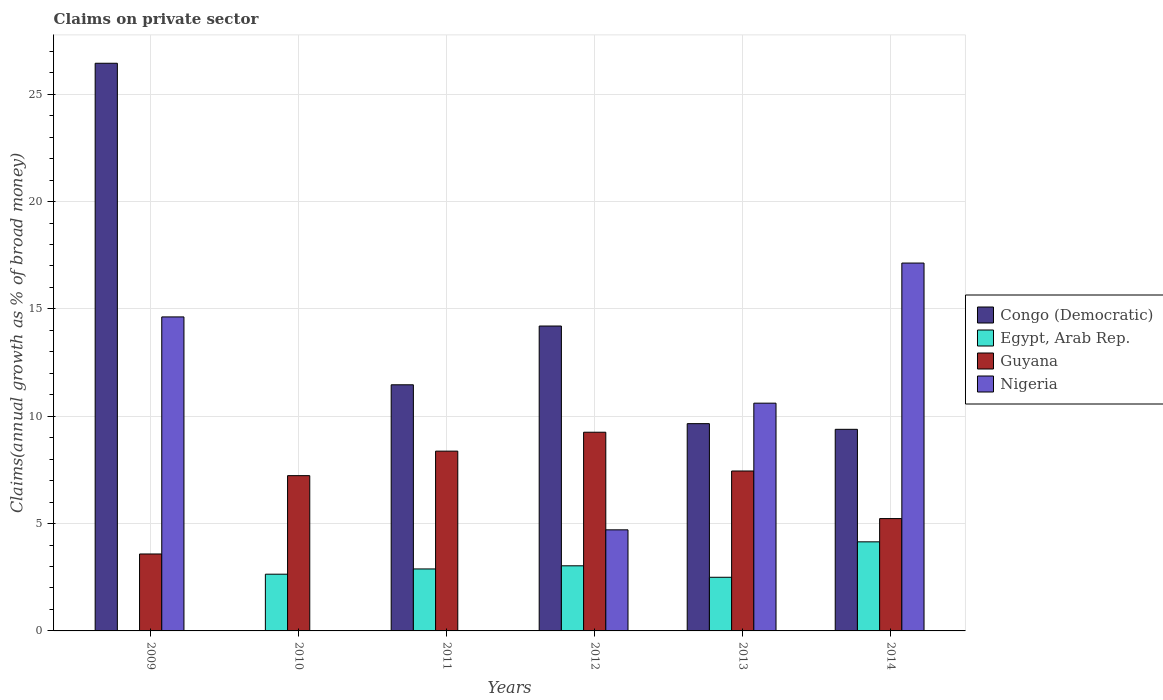How many different coloured bars are there?
Keep it short and to the point. 4. How many groups of bars are there?
Ensure brevity in your answer.  6. How many bars are there on the 2nd tick from the right?
Your answer should be compact. 4. In how many cases, is the number of bars for a given year not equal to the number of legend labels?
Your answer should be very brief. 3. What is the percentage of broad money claimed on private sector in Guyana in 2013?
Give a very brief answer. 7.45. Across all years, what is the maximum percentage of broad money claimed on private sector in Nigeria?
Offer a terse response. 17.13. What is the total percentage of broad money claimed on private sector in Nigeria in the graph?
Give a very brief answer. 47.08. What is the difference between the percentage of broad money claimed on private sector in Guyana in 2009 and that in 2014?
Make the answer very short. -1.65. What is the difference between the percentage of broad money claimed on private sector in Guyana in 2010 and the percentage of broad money claimed on private sector in Egypt, Arab Rep. in 2014?
Provide a short and direct response. 3.08. What is the average percentage of broad money claimed on private sector in Egypt, Arab Rep. per year?
Your response must be concise. 2.54. In the year 2009, what is the difference between the percentage of broad money claimed on private sector in Guyana and percentage of broad money claimed on private sector in Congo (Democratic)?
Give a very brief answer. -22.86. What is the ratio of the percentage of broad money claimed on private sector in Guyana in 2011 to that in 2012?
Your answer should be very brief. 0.9. Is the percentage of broad money claimed on private sector in Guyana in 2011 less than that in 2012?
Your response must be concise. Yes. Is the difference between the percentage of broad money claimed on private sector in Guyana in 2011 and 2014 greater than the difference between the percentage of broad money claimed on private sector in Congo (Democratic) in 2011 and 2014?
Your answer should be compact. Yes. What is the difference between the highest and the second highest percentage of broad money claimed on private sector in Guyana?
Your response must be concise. 0.88. What is the difference between the highest and the lowest percentage of broad money claimed on private sector in Congo (Democratic)?
Make the answer very short. 26.44. Is the sum of the percentage of broad money claimed on private sector in Congo (Democratic) in 2012 and 2013 greater than the maximum percentage of broad money claimed on private sector in Egypt, Arab Rep. across all years?
Your answer should be compact. Yes. Is it the case that in every year, the sum of the percentage of broad money claimed on private sector in Congo (Democratic) and percentage of broad money claimed on private sector in Guyana is greater than the sum of percentage of broad money claimed on private sector in Nigeria and percentage of broad money claimed on private sector in Egypt, Arab Rep.?
Offer a very short reply. No. Is it the case that in every year, the sum of the percentage of broad money claimed on private sector in Congo (Democratic) and percentage of broad money claimed on private sector in Guyana is greater than the percentage of broad money claimed on private sector in Egypt, Arab Rep.?
Provide a short and direct response. Yes. How many bars are there?
Give a very brief answer. 20. Are all the bars in the graph horizontal?
Offer a terse response. No. How many years are there in the graph?
Give a very brief answer. 6. Does the graph contain any zero values?
Your answer should be very brief. Yes. Does the graph contain grids?
Make the answer very short. Yes. Where does the legend appear in the graph?
Your response must be concise. Center right. What is the title of the graph?
Give a very brief answer. Claims on private sector. Does "Switzerland" appear as one of the legend labels in the graph?
Provide a short and direct response. No. What is the label or title of the X-axis?
Your answer should be compact. Years. What is the label or title of the Y-axis?
Your answer should be very brief. Claims(annual growth as % of broad money). What is the Claims(annual growth as % of broad money) of Congo (Democratic) in 2009?
Provide a short and direct response. 26.44. What is the Claims(annual growth as % of broad money) of Egypt, Arab Rep. in 2009?
Provide a short and direct response. 0. What is the Claims(annual growth as % of broad money) of Guyana in 2009?
Offer a very short reply. 3.58. What is the Claims(annual growth as % of broad money) in Nigeria in 2009?
Your answer should be very brief. 14.63. What is the Claims(annual growth as % of broad money) of Congo (Democratic) in 2010?
Your answer should be very brief. 0. What is the Claims(annual growth as % of broad money) of Egypt, Arab Rep. in 2010?
Provide a short and direct response. 2.64. What is the Claims(annual growth as % of broad money) of Guyana in 2010?
Give a very brief answer. 7.23. What is the Claims(annual growth as % of broad money) of Nigeria in 2010?
Offer a terse response. 0. What is the Claims(annual growth as % of broad money) of Congo (Democratic) in 2011?
Your answer should be compact. 11.46. What is the Claims(annual growth as % of broad money) of Egypt, Arab Rep. in 2011?
Your response must be concise. 2.89. What is the Claims(annual growth as % of broad money) of Guyana in 2011?
Make the answer very short. 8.37. What is the Claims(annual growth as % of broad money) of Nigeria in 2011?
Offer a very short reply. 0. What is the Claims(annual growth as % of broad money) in Congo (Democratic) in 2012?
Your response must be concise. 14.2. What is the Claims(annual growth as % of broad money) of Egypt, Arab Rep. in 2012?
Provide a succinct answer. 3.03. What is the Claims(annual growth as % of broad money) in Guyana in 2012?
Provide a succinct answer. 9.25. What is the Claims(annual growth as % of broad money) in Nigeria in 2012?
Ensure brevity in your answer.  4.71. What is the Claims(annual growth as % of broad money) of Congo (Democratic) in 2013?
Ensure brevity in your answer.  9.65. What is the Claims(annual growth as % of broad money) of Egypt, Arab Rep. in 2013?
Your answer should be compact. 2.5. What is the Claims(annual growth as % of broad money) in Guyana in 2013?
Your response must be concise. 7.45. What is the Claims(annual growth as % of broad money) in Nigeria in 2013?
Your response must be concise. 10.61. What is the Claims(annual growth as % of broad money) in Congo (Democratic) in 2014?
Provide a succinct answer. 9.39. What is the Claims(annual growth as % of broad money) in Egypt, Arab Rep. in 2014?
Your answer should be compact. 4.15. What is the Claims(annual growth as % of broad money) in Guyana in 2014?
Make the answer very short. 5.23. What is the Claims(annual growth as % of broad money) in Nigeria in 2014?
Your answer should be compact. 17.13. Across all years, what is the maximum Claims(annual growth as % of broad money) in Congo (Democratic)?
Ensure brevity in your answer.  26.44. Across all years, what is the maximum Claims(annual growth as % of broad money) in Egypt, Arab Rep.?
Offer a terse response. 4.15. Across all years, what is the maximum Claims(annual growth as % of broad money) of Guyana?
Offer a very short reply. 9.25. Across all years, what is the maximum Claims(annual growth as % of broad money) of Nigeria?
Provide a short and direct response. 17.13. Across all years, what is the minimum Claims(annual growth as % of broad money) in Congo (Democratic)?
Your answer should be compact. 0. Across all years, what is the minimum Claims(annual growth as % of broad money) in Guyana?
Offer a terse response. 3.58. What is the total Claims(annual growth as % of broad money) of Congo (Democratic) in the graph?
Your response must be concise. 71.15. What is the total Claims(annual growth as % of broad money) in Egypt, Arab Rep. in the graph?
Your response must be concise. 15.21. What is the total Claims(annual growth as % of broad money) of Guyana in the graph?
Your response must be concise. 41.13. What is the total Claims(annual growth as % of broad money) in Nigeria in the graph?
Provide a short and direct response. 47.08. What is the difference between the Claims(annual growth as % of broad money) in Guyana in 2009 and that in 2010?
Give a very brief answer. -3.65. What is the difference between the Claims(annual growth as % of broad money) of Congo (Democratic) in 2009 and that in 2011?
Your answer should be very brief. 14.98. What is the difference between the Claims(annual growth as % of broad money) in Guyana in 2009 and that in 2011?
Your answer should be very brief. -4.79. What is the difference between the Claims(annual growth as % of broad money) of Congo (Democratic) in 2009 and that in 2012?
Your response must be concise. 12.24. What is the difference between the Claims(annual growth as % of broad money) of Guyana in 2009 and that in 2012?
Keep it short and to the point. -5.67. What is the difference between the Claims(annual growth as % of broad money) in Nigeria in 2009 and that in 2012?
Give a very brief answer. 9.92. What is the difference between the Claims(annual growth as % of broad money) in Congo (Democratic) in 2009 and that in 2013?
Your answer should be compact. 16.79. What is the difference between the Claims(annual growth as % of broad money) of Guyana in 2009 and that in 2013?
Make the answer very short. -3.87. What is the difference between the Claims(annual growth as % of broad money) in Nigeria in 2009 and that in 2013?
Provide a short and direct response. 4.02. What is the difference between the Claims(annual growth as % of broad money) of Congo (Democratic) in 2009 and that in 2014?
Ensure brevity in your answer.  17.05. What is the difference between the Claims(annual growth as % of broad money) of Guyana in 2009 and that in 2014?
Your answer should be compact. -1.65. What is the difference between the Claims(annual growth as % of broad money) of Nigeria in 2009 and that in 2014?
Give a very brief answer. -2.51. What is the difference between the Claims(annual growth as % of broad money) of Egypt, Arab Rep. in 2010 and that in 2011?
Your answer should be very brief. -0.24. What is the difference between the Claims(annual growth as % of broad money) of Guyana in 2010 and that in 2011?
Give a very brief answer. -1.14. What is the difference between the Claims(annual growth as % of broad money) in Egypt, Arab Rep. in 2010 and that in 2012?
Your response must be concise. -0.39. What is the difference between the Claims(annual growth as % of broad money) of Guyana in 2010 and that in 2012?
Your response must be concise. -2.02. What is the difference between the Claims(annual growth as % of broad money) in Egypt, Arab Rep. in 2010 and that in 2013?
Offer a very short reply. 0.14. What is the difference between the Claims(annual growth as % of broad money) in Guyana in 2010 and that in 2013?
Offer a terse response. -0.22. What is the difference between the Claims(annual growth as % of broad money) of Egypt, Arab Rep. in 2010 and that in 2014?
Give a very brief answer. -1.51. What is the difference between the Claims(annual growth as % of broad money) of Guyana in 2010 and that in 2014?
Your answer should be compact. 2. What is the difference between the Claims(annual growth as % of broad money) in Congo (Democratic) in 2011 and that in 2012?
Offer a very short reply. -2.74. What is the difference between the Claims(annual growth as % of broad money) in Egypt, Arab Rep. in 2011 and that in 2012?
Provide a succinct answer. -0.15. What is the difference between the Claims(annual growth as % of broad money) of Guyana in 2011 and that in 2012?
Provide a succinct answer. -0.88. What is the difference between the Claims(annual growth as % of broad money) in Congo (Democratic) in 2011 and that in 2013?
Keep it short and to the point. 1.81. What is the difference between the Claims(annual growth as % of broad money) of Egypt, Arab Rep. in 2011 and that in 2013?
Your answer should be very brief. 0.39. What is the difference between the Claims(annual growth as % of broad money) in Guyana in 2011 and that in 2013?
Provide a short and direct response. 0.93. What is the difference between the Claims(annual growth as % of broad money) in Congo (Democratic) in 2011 and that in 2014?
Make the answer very short. 2.07. What is the difference between the Claims(annual growth as % of broad money) in Egypt, Arab Rep. in 2011 and that in 2014?
Offer a terse response. -1.26. What is the difference between the Claims(annual growth as % of broad money) of Guyana in 2011 and that in 2014?
Your response must be concise. 3.14. What is the difference between the Claims(annual growth as % of broad money) in Congo (Democratic) in 2012 and that in 2013?
Offer a terse response. 4.55. What is the difference between the Claims(annual growth as % of broad money) in Egypt, Arab Rep. in 2012 and that in 2013?
Your answer should be compact. 0.53. What is the difference between the Claims(annual growth as % of broad money) in Guyana in 2012 and that in 2013?
Keep it short and to the point. 1.81. What is the difference between the Claims(annual growth as % of broad money) in Nigeria in 2012 and that in 2013?
Give a very brief answer. -5.9. What is the difference between the Claims(annual growth as % of broad money) of Congo (Democratic) in 2012 and that in 2014?
Offer a very short reply. 4.81. What is the difference between the Claims(annual growth as % of broad money) of Egypt, Arab Rep. in 2012 and that in 2014?
Give a very brief answer. -1.12. What is the difference between the Claims(annual growth as % of broad money) in Guyana in 2012 and that in 2014?
Offer a very short reply. 4.02. What is the difference between the Claims(annual growth as % of broad money) in Nigeria in 2012 and that in 2014?
Provide a succinct answer. -12.43. What is the difference between the Claims(annual growth as % of broad money) of Congo (Democratic) in 2013 and that in 2014?
Offer a very short reply. 0.26. What is the difference between the Claims(annual growth as % of broad money) in Egypt, Arab Rep. in 2013 and that in 2014?
Ensure brevity in your answer.  -1.65. What is the difference between the Claims(annual growth as % of broad money) in Guyana in 2013 and that in 2014?
Make the answer very short. 2.22. What is the difference between the Claims(annual growth as % of broad money) in Nigeria in 2013 and that in 2014?
Give a very brief answer. -6.53. What is the difference between the Claims(annual growth as % of broad money) of Congo (Democratic) in 2009 and the Claims(annual growth as % of broad money) of Egypt, Arab Rep. in 2010?
Give a very brief answer. 23.8. What is the difference between the Claims(annual growth as % of broad money) in Congo (Democratic) in 2009 and the Claims(annual growth as % of broad money) in Guyana in 2010?
Your response must be concise. 19.21. What is the difference between the Claims(annual growth as % of broad money) of Congo (Democratic) in 2009 and the Claims(annual growth as % of broad money) of Egypt, Arab Rep. in 2011?
Your answer should be very brief. 23.56. What is the difference between the Claims(annual growth as % of broad money) of Congo (Democratic) in 2009 and the Claims(annual growth as % of broad money) of Guyana in 2011?
Provide a short and direct response. 18.07. What is the difference between the Claims(annual growth as % of broad money) in Congo (Democratic) in 2009 and the Claims(annual growth as % of broad money) in Egypt, Arab Rep. in 2012?
Your answer should be very brief. 23.41. What is the difference between the Claims(annual growth as % of broad money) of Congo (Democratic) in 2009 and the Claims(annual growth as % of broad money) of Guyana in 2012?
Offer a very short reply. 17.19. What is the difference between the Claims(annual growth as % of broad money) in Congo (Democratic) in 2009 and the Claims(annual growth as % of broad money) in Nigeria in 2012?
Offer a terse response. 21.73. What is the difference between the Claims(annual growth as % of broad money) in Guyana in 2009 and the Claims(annual growth as % of broad money) in Nigeria in 2012?
Ensure brevity in your answer.  -1.12. What is the difference between the Claims(annual growth as % of broad money) in Congo (Democratic) in 2009 and the Claims(annual growth as % of broad money) in Egypt, Arab Rep. in 2013?
Your answer should be compact. 23.94. What is the difference between the Claims(annual growth as % of broad money) of Congo (Democratic) in 2009 and the Claims(annual growth as % of broad money) of Guyana in 2013?
Give a very brief answer. 18.99. What is the difference between the Claims(annual growth as % of broad money) in Congo (Democratic) in 2009 and the Claims(annual growth as % of broad money) in Nigeria in 2013?
Provide a succinct answer. 15.83. What is the difference between the Claims(annual growth as % of broad money) of Guyana in 2009 and the Claims(annual growth as % of broad money) of Nigeria in 2013?
Ensure brevity in your answer.  -7.03. What is the difference between the Claims(annual growth as % of broad money) of Congo (Democratic) in 2009 and the Claims(annual growth as % of broad money) of Egypt, Arab Rep. in 2014?
Offer a very short reply. 22.29. What is the difference between the Claims(annual growth as % of broad money) of Congo (Democratic) in 2009 and the Claims(annual growth as % of broad money) of Guyana in 2014?
Your response must be concise. 21.21. What is the difference between the Claims(annual growth as % of broad money) of Congo (Democratic) in 2009 and the Claims(annual growth as % of broad money) of Nigeria in 2014?
Offer a very short reply. 9.31. What is the difference between the Claims(annual growth as % of broad money) in Guyana in 2009 and the Claims(annual growth as % of broad money) in Nigeria in 2014?
Provide a short and direct response. -13.55. What is the difference between the Claims(annual growth as % of broad money) of Egypt, Arab Rep. in 2010 and the Claims(annual growth as % of broad money) of Guyana in 2011?
Provide a short and direct response. -5.73. What is the difference between the Claims(annual growth as % of broad money) in Egypt, Arab Rep. in 2010 and the Claims(annual growth as % of broad money) in Guyana in 2012?
Provide a short and direct response. -6.61. What is the difference between the Claims(annual growth as % of broad money) of Egypt, Arab Rep. in 2010 and the Claims(annual growth as % of broad money) of Nigeria in 2012?
Provide a short and direct response. -2.07. What is the difference between the Claims(annual growth as % of broad money) in Guyana in 2010 and the Claims(annual growth as % of broad money) in Nigeria in 2012?
Your answer should be very brief. 2.52. What is the difference between the Claims(annual growth as % of broad money) in Egypt, Arab Rep. in 2010 and the Claims(annual growth as % of broad money) in Guyana in 2013?
Provide a short and direct response. -4.81. What is the difference between the Claims(annual growth as % of broad money) in Egypt, Arab Rep. in 2010 and the Claims(annual growth as % of broad money) in Nigeria in 2013?
Provide a short and direct response. -7.97. What is the difference between the Claims(annual growth as % of broad money) of Guyana in 2010 and the Claims(annual growth as % of broad money) of Nigeria in 2013?
Your answer should be very brief. -3.38. What is the difference between the Claims(annual growth as % of broad money) in Egypt, Arab Rep. in 2010 and the Claims(annual growth as % of broad money) in Guyana in 2014?
Provide a succinct answer. -2.59. What is the difference between the Claims(annual growth as % of broad money) of Egypt, Arab Rep. in 2010 and the Claims(annual growth as % of broad money) of Nigeria in 2014?
Keep it short and to the point. -14.49. What is the difference between the Claims(annual growth as % of broad money) of Guyana in 2010 and the Claims(annual growth as % of broad money) of Nigeria in 2014?
Your response must be concise. -9.9. What is the difference between the Claims(annual growth as % of broad money) of Congo (Democratic) in 2011 and the Claims(annual growth as % of broad money) of Egypt, Arab Rep. in 2012?
Offer a very short reply. 8.43. What is the difference between the Claims(annual growth as % of broad money) in Congo (Democratic) in 2011 and the Claims(annual growth as % of broad money) in Guyana in 2012?
Offer a terse response. 2.21. What is the difference between the Claims(annual growth as % of broad money) of Congo (Democratic) in 2011 and the Claims(annual growth as % of broad money) of Nigeria in 2012?
Your answer should be compact. 6.76. What is the difference between the Claims(annual growth as % of broad money) in Egypt, Arab Rep. in 2011 and the Claims(annual growth as % of broad money) in Guyana in 2012?
Offer a very short reply. -6.37. What is the difference between the Claims(annual growth as % of broad money) of Egypt, Arab Rep. in 2011 and the Claims(annual growth as % of broad money) of Nigeria in 2012?
Keep it short and to the point. -1.82. What is the difference between the Claims(annual growth as % of broad money) in Guyana in 2011 and the Claims(annual growth as % of broad money) in Nigeria in 2012?
Your response must be concise. 3.67. What is the difference between the Claims(annual growth as % of broad money) in Congo (Democratic) in 2011 and the Claims(annual growth as % of broad money) in Egypt, Arab Rep. in 2013?
Give a very brief answer. 8.97. What is the difference between the Claims(annual growth as % of broad money) in Congo (Democratic) in 2011 and the Claims(annual growth as % of broad money) in Guyana in 2013?
Give a very brief answer. 4.02. What is the difference between the Claims(annual growth as % of broad money) in Congo (Democratic) in 2011 and the Claims(annual growth as % of broad money) in Nigeria in 2013?
Your response must be concise. 0.86. What is the difference between the Claims(annual growth as % of broad money) of Egypt, Arab Rep. in 2011 and the Claims(annual growth as % of broad money) of Guyana in 2013?
Offer a terse response. -4.56. What is the difference between the Claims(annual growth as % of broad money) in Egypt, Arab Rep. in 2011 and the Claims(annual growth as % of broad money) in Nigeria in 2013?
Your answer should be very brief. -7.72. What is the difference between the Claims(annual growth as % of broad money) in Guyana in 2011 and the Claims(annual growth as % of broad money) in Nigeria in 2013?
Provide a succinct answer. -2.23. What is the difference between the Claims(annual growth as % of broad money) of Congo (Democratic) in 2011 and the Claims(annual growth as % of broad money) of Egypt, Arab Rep. in 2014?
Provide a succinct answer. 7.32. What is the difference between the Claims(annual growth as % of broad money) of Congo (Democratic) in 2011 and the Claims(annual growth as % of broad money) of Guyana in 2014?
Keep it short and to the point. 6.23. What is the difference between the Claims(annual growth as % of broad money) of Congo (Democratic) in 2011 and the Claims(annual growth as % of broad money) of Nigeria in 2014?
Make the answer very short. -5.67. What is the difference between the Claims(annual growth as % of broad money) in Egypt, Arab Rep. in 2011 and the Claims(annual growth as % of broad money) in Guyana in 2014?
Make the answer very short. -2.35. What is the difference between the Claims(annual growth as % of broad money) in Egypt, Arab Rep. in 2011 and the Claims(annual growth as % of broad money) in Nigeria in 2014?
Your answer should be compact. -14.25. What is the difference between the Claims(annual growth as % of broad money) in Guyana in 2011 and the Claims(annual growth as % of broad money) in Nigeria in 2014?
Your response must be concise. -8.76. What is the difference between the Claims(annual growth as % of broad money) of Congo (Democratic) in 2012 and the Claims(annual growth as % of broad money) of Egypt, Arab Rep. in 2013?
Offer a very short reply. 11.7. What is the difference between the Claims(annual growth as % of broad money) of Congo (Democratic) in 2012 and the Claims(annual growth as % of broad money) of Guyana in 2013?
Your answer should be very brief. 6.75. What is the difference between the Claims(annual growth as % of broad money) in Congo (Democratic) in 2012 and the Claims(annual growth as % of broad money) in Nigeria in 2013?
Make the answer very short. 3.59. What is the difference between the Claims(annual growth as % of broad money) in Egypt, Arab Rep. in 2012 and the Claims(annual growth as % of broad money) in Guyana in 2013?
Your answer should be very brief. -4.42. What is the difference between the Claims(annual growth as % of broad money) in Egypt, Arab Rep. in 2012 and the Claims(annual growth as % of broad money) in Nigeria in 2013?
Your response must be concise. -7.58. What is the difference between the Claims(annual growth as % of broad money) in Guyana in 2012 and the Claims(annual growth as % of broad money) in Nigeria in 2013?
Keep it short and to the point. -1.35. What is the difference between the Claims(annual growth as % of broad money) of Congo (Democratic) in 2012 and the Claims(annual growth as % of broad money) of Egypt, Arab Rep. in 2014?
Ensure brevity in your answer.  10.05. What is the difference between the Claims(annual growth as % of broad money) of Congo (Democratic) in 2012 and the Claims(annual growth as % of broad money) of Guyana in 2014?
Your answer should be compact. 8.97. What is the difference between the Claims(annual growth as % of broad money) of Congo (Democratic) in 2012 and the Claims(annual growth as % of broad money) of Nigeria in 2014?
Provide a succinct answer. -2.93. What is the difference between the Claims(annual growth as % of broad money) of Egypt, Arab Rep. in 2012 and the Claims(annual growth as % of broad money) of Guyana in 2014?
Provide a short and direct response. -2.2. What is the difference between the Claims(annual growth as % of broad money) of Egypt, Arab Rep. in 2012 and the Claims(annual growth as % of broad money) of Nigeria in 2014?
Your response must be concise. -14.1. What is the difference between the Claims(annual growth as % of broad money) in Guyana in 2012 and the Claims(annual growth as % of broad money) in Nigeria in 2014?
Your answer should be very brief. -7.88. What is the difference between the Claims(annual growth as % of broad money) of Congo (Democratic) in 2013 and the Claims(annual growth as % of broad money) of Egypt, Arab Rep. in 2014?
Offer a very short reply. 5.51. What is the difference between the Claims(annual growth as % of broad money) in Congo (Democratic) in 2013 and the Claims(annual growth as % of broad money) in Guyana in 2014?
Your answer should be very brief. 4.42. What is the difference between the Claims(annual growth as % of broad money) of Congo (Democratic) in 2013 and the Claims(annual growth as % of broad money) of Nigeria in 2014?
Provide a succinct answer. -7.48. What is the difference between the Claims(annual growth as % of broad money) in Egypt, Arab Rep. in 2013 and the Claims(annual growth as % of broad money) in Guyana in 2014?
Give a very brief answer. -2.73. What is the difference between the Claims(annual growth as % of broad money) in Egypt, Arab Rep. in 2013 and the Claims(annual growth as % of broad money) in Nigeria in 2014?
Ensure brevity in your answer.  -14.64. What is the difference between the Claims(annual growth as % of broad money) in Guyana in 2013 and the Claims(annual growth as % of broad money) in Nigeria in 2014?
Keep it short and to the point. -9.69. What is the average Claims(annual growth as % of broad money) in Congo (Democratic) per year?
Provide a short and direct response. 11.86. What is the average Claims(annual growth as % of broad money) in Egypt, Arab Rep. per year?
Provide a succinct answer. 2.54. What is the average Claims(annual growth as % of broad money) in Guyana per year?
Provide a short and direct response. 6.85. What is the average Claims(annual growth as % of broad money) of Nigeria per year?
Your answer should be very brief. 7.85. In the year 2009, what is the difference between the Claims(annual growth as % of broad money) of Congo (Democratic) and Claims(annual growth as % of broad money) of Guyana?
Keep it short and to the point. 22.86. In the year 2009, what is the difference between the Claims(annual growth as % of broad money) in Congo (Democratic) and Claims(annual growth as % of broad money) in Nigeria?
Keep it short and to the point. 11.82. In the year 2009, what is the difference between the Claims(annual growth as % of broad money) of Guyana and Claims(annual growth as % of broad money) of Nigeria?
Give a very brief answer. -11.04. In the year 2010, what is the difference between the Claims(annual growth as % of broad money) in Egypt, Arab Rep. and Claims(annual growth as % of broad money) in Guyana?
Your answer should be very brief. -4.59. In the year 2011, what is the difference between the Claims(annual growth as % of broad money) of Congo (Democratic) and Claims(annual growth as % of broad money) of Egypt, Arab Rep.?
Provide a succinct answer. 8.58. In the year 2011, what is the difference between the Claims(annual growth as % of broad money) of Congo (Democratic) and Claims(annual growth as % of broad money) of Guyana?
Offer a very short reply. 3.09. In the year 2011, what is the difference between the Claims(annual growth as % of broad money) of Egypt, Arab Rep. and Claims(annual growth as % of broad money) of Guyana?
Offer a terse response. -5.49. In the year 2012, what is the difference between the Claims(annual growth as % of broad money) of Congo (Democratic) and Claims(annual growth as % of broad money) of Egypt, Arab Rep.?
Offer a terse response. 11.17. In the year 2012, what is the difference between the Claims(annual growth as % of broad money) in Congo (Democratic) and Claims(annual growth as % of broad money) in Guyana?
Keep it short and to the point. 4.95. In the year 2012, what is the difference between the Claims(annual growth as % of broad money) in Congo (Democratic) and Claims(annual growth as % of broad money) in Nigeria?
Provide a short and direct response. 9.49. In the year 2012, what is the difference between the Claims(annual growth as % of broad money) in Egypt, Arab Rep. and Claims(annual growth as % of broad money) in Guyana?
Provide a short and direct response. -6.22. In the year 2012, what is the difference between the Claims(annual growth as % of broad money) in Egypt, Arab Rep. and Claims(annual growth as % of broad money) in Nigeria?
Offer a very short reply. -1.68. In the year 2012, what is the difference between the Claims(annual growth as % of broad money) of Guyana and Claims(annual growth as % of broad money) of Nigeria?
Keep it short and to the point. 4.55. In the year 2013, what is the difference between the Claims(annual growth as % of broad money) in Congo (Democratic) and Claims(annual growth as % of broad money) in Egypt, Arab Rep.?
Provide a short and direct response. 7.16. In the year 2013, what is the difference between the Claims(annual growth as % of broad money) of Congo (Democratic) and Claims(annual growth as % of broad money) of Guyana?
Offer a very short reply. 2.21. In the year 2013, what is the difference between the Claims(annual growth as % of broad money) in Congo (Democratic) and Claims(annual growth as % of broad money) in Nigeria?
Provide a short and direct response. -0.95. In the year 2013, what is the difference between the Claims(annual growth as % of broad money) of Egypt, Arab Rep. and Claims(annual growth as % of broad money) of Guyana?
Make the answer very short. -4.95. In the year 2013, what is the difference between the Claims(annual growth as % of broad money) of Egypt, Arab Rep. and Claims(annual growth as % of broad money) of Nigeria?
Make the answer very short. -8.11. In the year 2013, what is the difference between the Claims(annual growth as % of broad money) in Guyana and Claims(annual growth as % of broad money) in Nigeria?
Offer a very short reply. -3.16. In the year 2014, what is the difference between the Claims(annual growth as % of broad money) of Congo (Democratic) and Claims(annual growth as % of broad money) of Egypt, Arab Rep.?
Make the answer very short. 5.24. In the year 2014, what is the difference between the Claims(annual growth as % of broad money) of Congo (Democratic) and Claims(annual growth as % of broad money) of Guyana?
Make the answer very short. 4.16. In the year 2014, what is the difference between the Claims(annual growth as % of broad money) in Congo (Democratic) and Claims(annual growth as % of broad money) in Nigeria?
Your response must be concise. -7.74. In the year 2014, what is the difference between the Claims(annual growth as % of broad money) of Egypt, Arab Rep. and Claims(annual growth as % of broad money) of Guyana?
Provide a short and direct response. -1.08. In the year 2014, what is the difference between the Claims(annual growth as % of broad money) in Egypt, Arab Rep. and Claims(annual growth as % of broad money) in Nigeria?
Your response must be concise. -12.99. In the year 2014, what is the difference between the Claims(annual growth as % of broad money) of Guyana and Claims(annual growth as % of broad money) of Nigeria?
Your answer should be compact. -11.9. What is the ratio of the Claims(annual growth as % of broad money) of Guyana in 2009 to that in 2010?
Ensure brevity in your answer.  0.5. What is the ratio of the Claims(annual growth as % of broad money) of Congo (Democratic) in 2009 to that in 2011?
Provide a succinct answer. 2.31. What is the ratio of the Claims(annual growth as % of broad money) in Guyana in 2009 to that in 2011?
Your answer should be very brief. 0.43. What is the ratio of the Claims(annual growth as % of broad money) of Congo (Democratic) in 2009 to that in 2012?
Provide a short and direct response. 1.86. What is the ratio of the Claims(annual growth as % of broad money) of Guyana in 2009 to that in 2012?
Your answer should be very brief. 0.39. What is the ratio of the Claims(annual growth as % of broad money) of Nigeria in 2009 to that in 2012?
Keep it short and to the point. 3.11. What is the ratio of the Claims(annual growth as % of broad money) in Congo (Democratic) in 2009 to that in 2013?
Ensure brevity in your answer.  2.74. What is the ratio of the Claims(annual growth as % of broad money) of Guyana in 2009 to that in 2013?
Make the answer very short. 0.48. What is the ratio of the Claims(annual growth as % of broad money) of Nigeria in 2009 to that in 2013?
Your response must be concise. 1.38. What is the ratio of the Claims(annual growth as % of broad money) in Congo (Democratic) in 2009 to that in 2014?
Offer a terse response. 2.82. What is the ratio of the Claims(annual growth as % of broad money) of Guyana in 2009 to that in 2014?
Ensure brevity in your answer.  0.69. What is the ratio of the Claims(annual growth as % of broad money) of Nigeria in 2009 to that in 2014?
Offer a very short reply. 0.85. What is the ratio of the Claims(annual growth as % of broad money) of Egypt, Arab Rep. in 2010 to that in 2011?
Your response must be concise. 0.92. What is the ratio of the Claims(annual growth as % of broad money) in Guyana in 2010 to that in 2011?
Your response must be concise. 0.86. What is the ratio of the Claims(annual growth as % of broad money) in Egypt, Arab Rep. in 2010 to that in 2012?
Provide a succinct answer. 0.87. What is the ratio of the Claims(annual growth as % of broad money) in Guyana in 2010 to that in 2012?
Provide a short and direct response. 0.78. What is the ratio of the Claims(annual growth as % of broad money) in Egypt, Arab Rep. in 2010 to that in 2013?
Provide a succinct answer. 1.06. What is the ratio of the Claims(annual growth as % of broad money) of Guyana in 2010 to that in 2013?
Ensure brevity in your answer.  0.97. What is the ratio of the Claims(annual growth as % of broad money) in Egypt, Arab Rep. in 2010 to that in 2014?
Provide a succinct answer. 0.64. What is the ratio of the Claims(annual growth as % of broad money) of Guyana in 2010 to that in 2014?
Make the answer very short. 1.38. What is the ratio of the Claims(annual growth as % of broad money) of Congo (Democratic) in 2011 to that in 2012?
Provide a succinct answer. 0.81. What is the ratio of the Claims(annual growth as % of broad money) in Egypt, Arab Rep. in 2011 to that in 2012?
Make the answer very short. 0.95. What is the ratio of the Claims(annual growth as % of broad money) of Guyana in 2011 to that in 2012?
Keep it short and to the point. 0.9. What is the ratio of the Claims(annual growth as % of broad money) of Congo (Democratic) in 2011 to that in 2013?
Provide a succinct answer. 1.19. What is the ratio of the Claims(annual growth as % of broad money) of Egypt, Arab Rep. in 2011 to that in 2013?
Provide a short and direct response. 1.16. What is the ratio of the Claims(annual growth as % of broad money) in Guyana in 2011 to that in 2013?
Ensure brevity in your answer.  1.12. What is the ratio of the Claims(annual growth as % of broad money) in Congo (Democratic) in 2011 to that in 2014?
Offer a very short reply. 1.22. What is the ratio of the Claims(annual growth as % of broad money) of Egypt, Arab Rep. in 2011 to that in 2014?
Provide a short and direct response. 0.7. What is the ratio of the Claims(annual growth as % of broad money) in Guyana in 2011 to that in 2014?
Make the answer very short. 1.6. What is the ratio of the Claims(annual growth as % of broad money) of Congo (Democratic) in 2012 to that in 2013?
Make the answer very short. 1.47. What is the ratio of the Claims(annual growth as % of broad money) of Egypt, Arab Rep. in 2012 to that in 2013?
Give a very brief answer. 1.21. What is the ratio of the Claims(annual growth as % of broad money) in Guyana in 2012 to that in 2013?
Offer a very short reply. 1.24. What is the ratio of the Claims(annual growth as % of broad money) of Nigeria in 2012 to that in 2013?
Ensure brevity in your answer.  0.44. What is the ratio of the Claims(annual growth as % of broad money) in Congo (Democratic) in 2012 to that in 2014?
Give a very brief answer. 1.51. What is the ratio of the Claims(annual growth as % of broad money) of Egypt, Arab Rep. in 2012 to that in 2014?
Offer a terse response. 0.73. What is the ratio of the Claims(annual growth as % of broad money) in Guyana in 2012 to that in 2014?
Keep it short and to the point. 1.77. What is the ratio of the Claims(annual growth as % of broad money) of Nigeria in 2012 to that in 2014?
Your answer should be compact. 0.27. What is the ratio of the Claims(annual growth as % of broad money) in Congo (Democratic) in 2013 to that in 2014?
Give a very brief answer. 1.03. What is the ratio of the Claims(annual growth as % of broad money) in Egypt, Arab Rep. in 2013 to that in 2014?
Your answer should be compact. 0.6. What is the ratio of the Claims(annual growth as % of broad money) of Guyana in 2013 to that in 2014?
Make the answer very short. 1.42. What is the ratio of the Claims(annual growth as % of broad money) of Nigeria in 2013 to that in 2014?
Offer a terse response. 0.62. What is the difference between the highest and the second highest Claims(annual growth as % of broad money) of Congo (Democratic)?
Offer a terse response. 12.24. What is the difference between the highest and the second highest Claims(annual growth as % of broad money) in Egypt, Arab Rep.?
Give a very brief answer. 1.12. What is the difference between the highest and the second highest Claims(annual growth as % of broad money) in Guyana?
Your answer should be very brief. 0.88. What is the difference between the highest and the second highest Claims(annual growth as % of broad money) of Nigeria?
Your answer should be compact. 2.51. What is the difference between the highest and the lowest Claims(annual growth as % of broad money) in Congo (Democratic)?
Provide a short and direct response. 26.44. What is the difference between the highest and the lowest Claims(annual growth as % of broad money) in Egypt, Arab Rep.?
Your answer should be compact. 4.15. What is the difference between the highest and the lowest Claims(annual growth as % of broad money) of Guyana?
Offer a very short reply. 5.67. What is the difference between the highest and the lowest Claims(annual growth as % of broad money) of Nigeria?
Give a very brief answer. 17.14. 